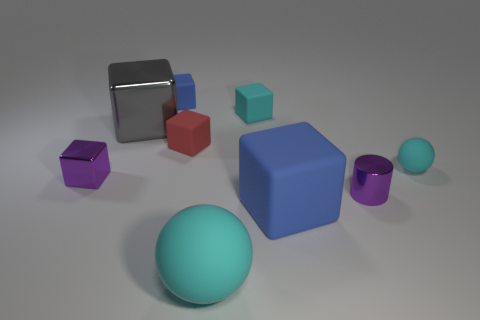There is a blue block in front of the metallic thing that is to the right of the big cube to the right of the small blue matte thing; how big is it?
Your answer should be compact. Large. Are there any purple blocks in front of the large ball?
Offer a very short reply. No. What size is the cyan cube that is made of the same material as the large cyan sphere?
Keep it short and to the point. Small. What number of other shiny objects have the same shape as the large cyan thing?
Your response must be concise. 0. Are the big blue thing and the small purple thing that is in front of the small metallic block made of the same material?
Offer a terse response. No. Is the number of cubes to the right of the tiny red rubber block greater than the number of large rubber balls?
Give a very brief answer. Yes. There is a big matte thing that is the same color as the small ball; what is its shape?
Offer a terse response. Sphere. Is there a cyan ball that has the same material as the tiny cylinder?
Offer a very short reply. No. Is the cyan ball behind the tiny purple block made of the same material as the small purple object right of the small metal block?
Offer a very short reply. No. Are there the same number of small blue things in front of the red matte block and tiny metallic things that are behind the cyan rubber cube?
Make the answer very short. Yes. 